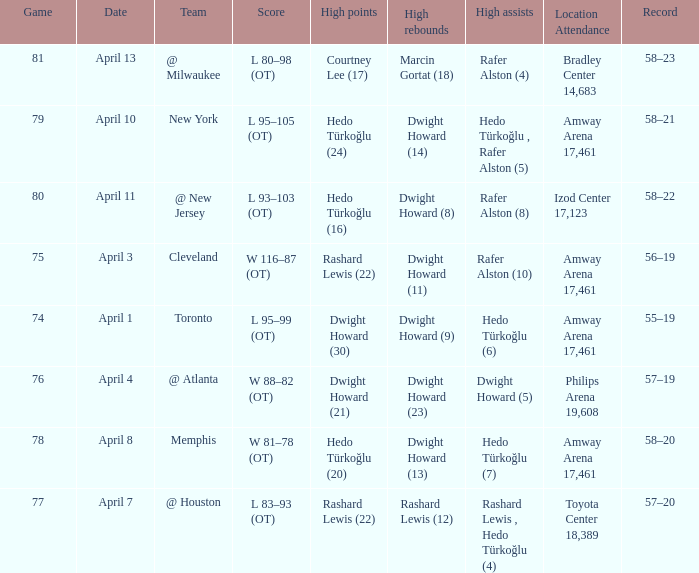Which player had the highest points in game 79? Hedo Türkoğlu (24). 